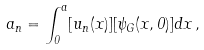<formula> <loc_0><loc_0><loc_500><loc_500>a _ { n } = \int _ { 0 } ^ { a } [ u _ { n } ( x ) ] [ \psi _ { G } ( x , 0 ) ] d x \, ,</formula> 